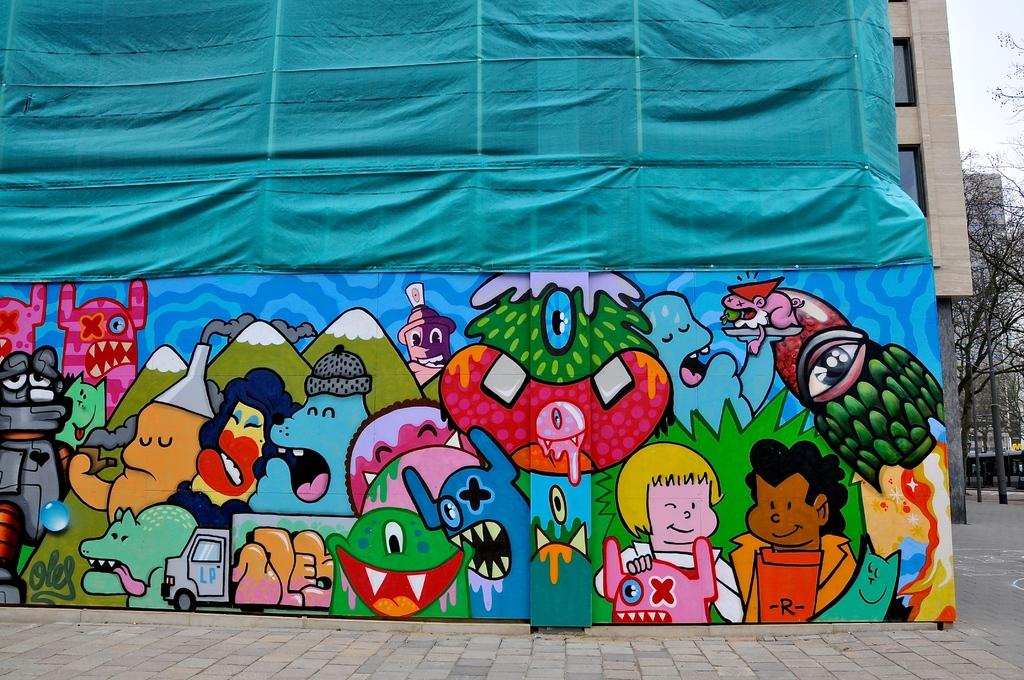What is on the wall in the image? There are pictures on the wall in the image. What type of structure is visible in the image? There is a building with windows in the image. What material is visible in the image? There is a cloth visible in the image. What type of vegetation is in the image? There are trees in the image. What is the tall, vertical object in the image? There is a pole in the image. What is visible above the structures and objects in the image? The sky is visible in the image. Can you tell me how many ants are crawling on the pole in the image? There are no ants present on the pole in the image. What type of goose is sitting on the roof of the building in the image? There are no geese present on the roof of the building in the image. 